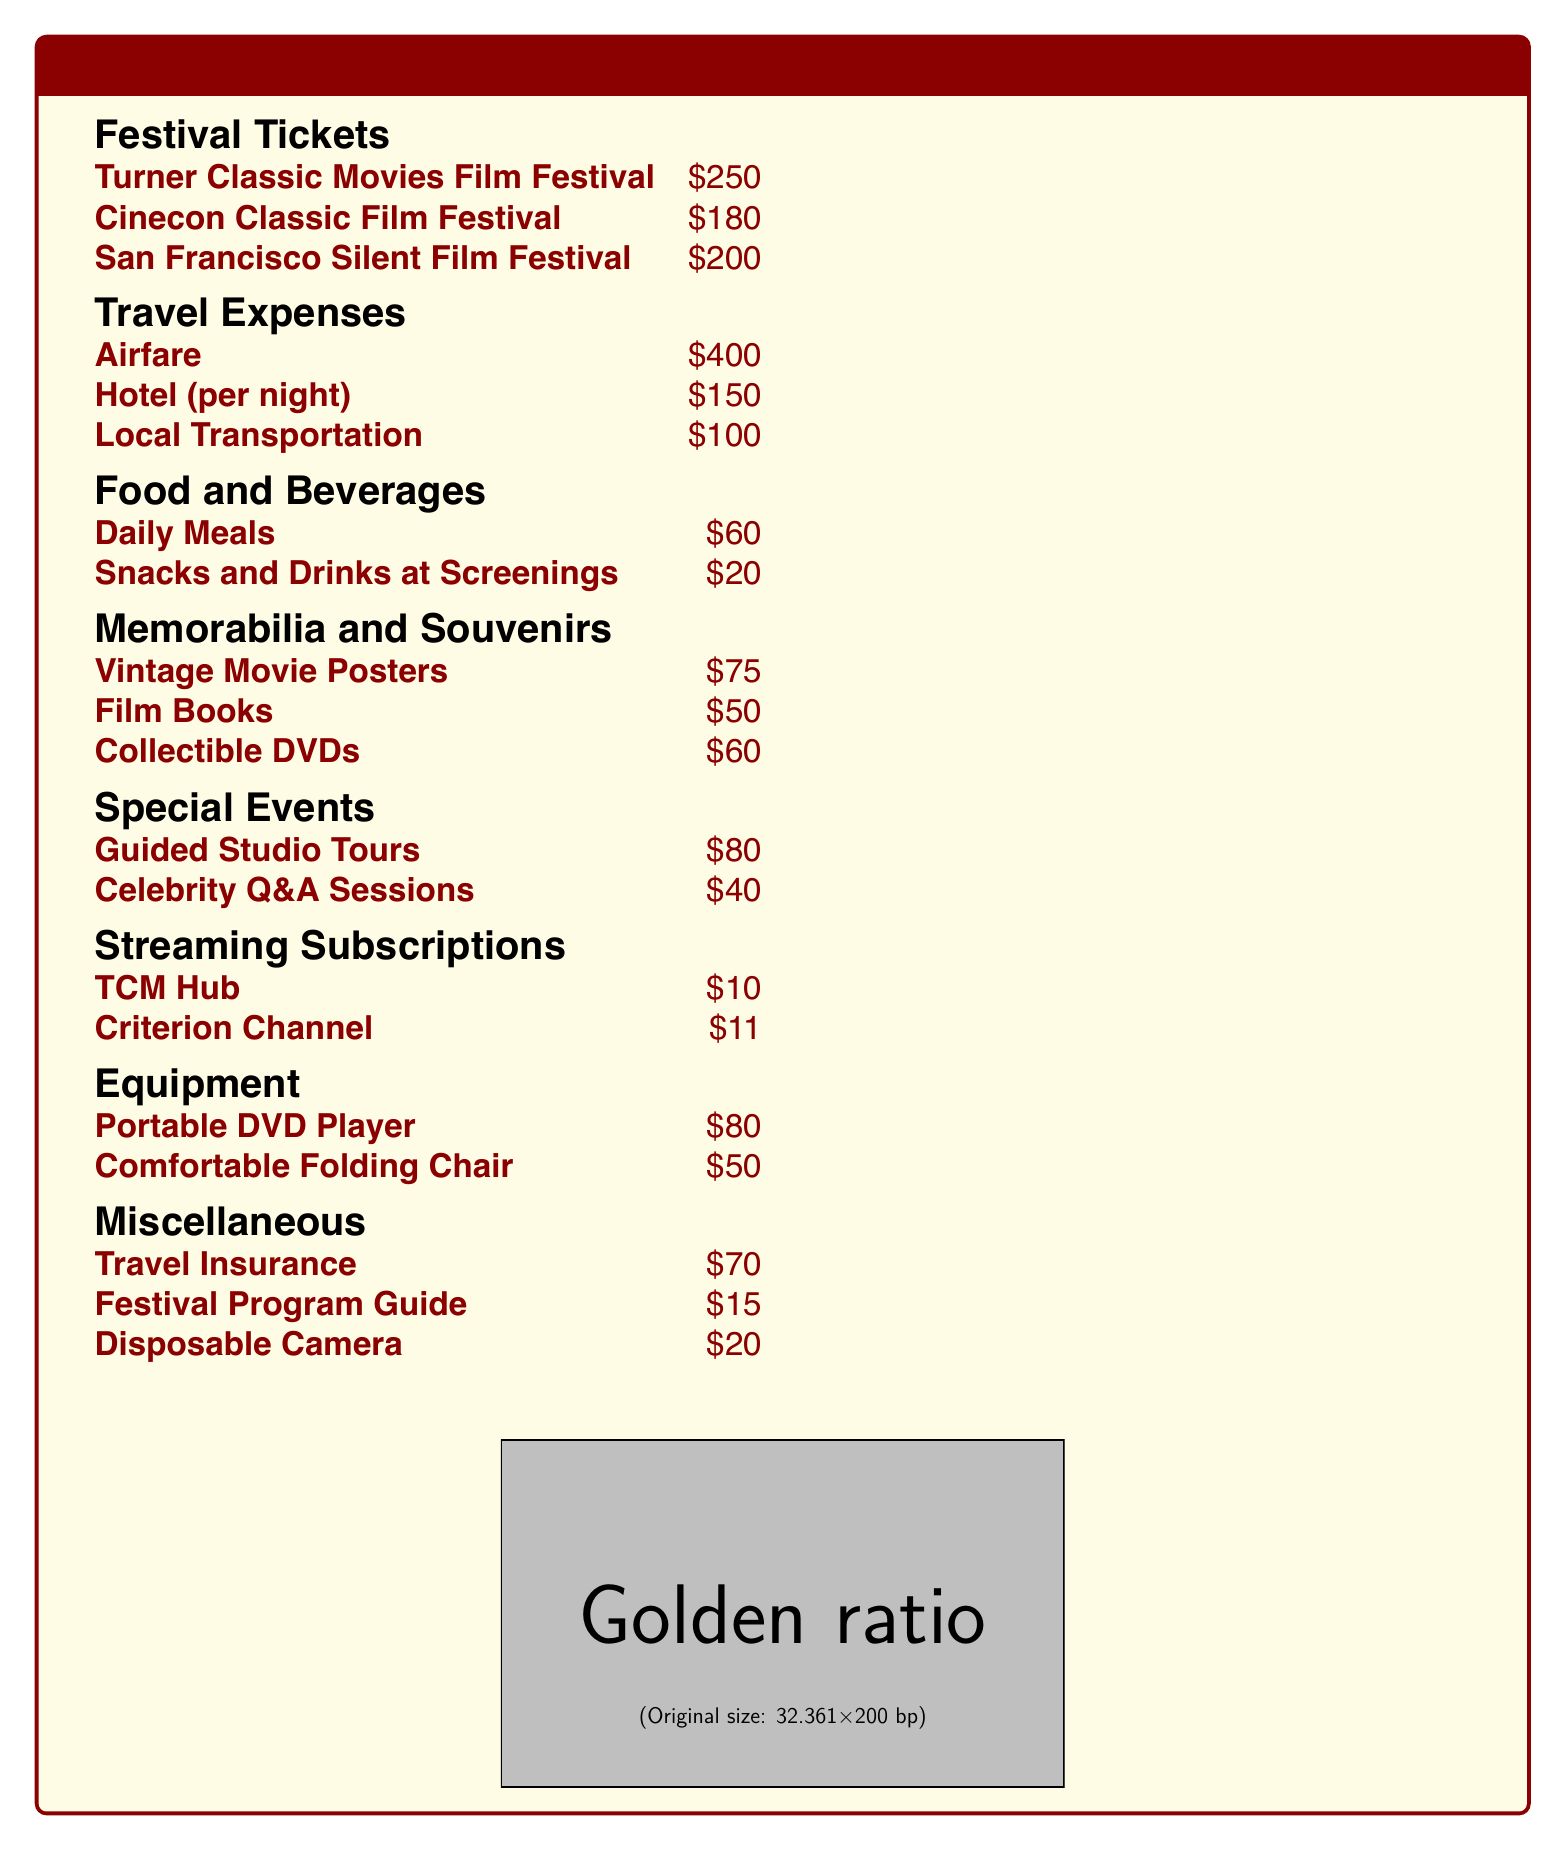What is the cost of the Turner Classic Movies Film Festival ticket? The cost of the Turner Classic Movies Film Festival ticket is listed in the document as $250.
Answer: $250 How much is allocated for airfare? Airfare is explicitly mentioned in the document with a cost of $400.
Answer: $400 What is the total daily cost for meals and snacks at screenings? The daily cost for meals is $60 and for snacks is $20. Therefore, the total is $60 + $20 = $80.
Answer: $80 How much is spent on memorabilia and souvenirs combined? The total cost for memorabilia and souvenirs is derived from adding the individual items: $75 (posters) + $50 (books) + $60 (DVDs) = $185.
Answer: $185 What is the charge for a Celebrity Q&A session? The document states that the charge for a Celebrity Q&A session is $40.
Answer: $40 What is the total cost of streaming subscriptions? The streaming subscription costs are $10 (TCM Hub) + $11 (Criterion Channel) = $21.
Answer: $21 How many nights is the hotel cost based on the document? The document lists the hotel cost as $150 "per night," indicating the cost is not fixed for multiple nights.
Answer: per night What is the budget for travel insurance? The budget for travel insurance is mentioned as $70 in the document.
Answer: $70 How much does a portable DVD player cost? The cost of a portable DVD player is listed in the document as $80.
Answer: $80 